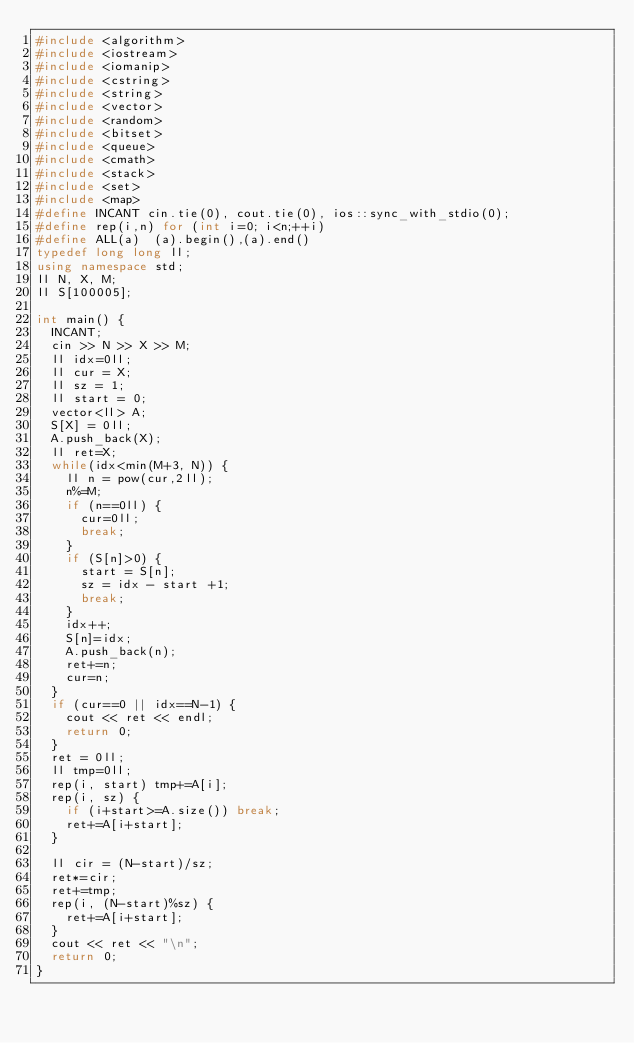<code> <loc_0><loc_0><loc_500><loc_500><_C++_>#include <algorithm>
#include <iostream>
#include <iomanip>
#include <cstring>
#include <string>
#include <vector>
#include <random>
#include <bitset>
#include <queue>
#include <cmath>
#include <stack>
#include <set>
#include <map>
#define INCANT cin.tie(0), cout.tie(0), ios::sync_with_stdio(0);
#define rep(i,n) for (int i=0; i<n;++i)
#define ALL(a)  (a).begin(),(a).end()
typedef long long ll;
using namespace std;
ll N, X, M;
ll S[100005];

int main() {
  INCANT;
  cin >> N >> X >> M;
  ll idx=0ll;
  ll cur = X;
  ll sz = 1;
  ll start = 0;
  vector<ll> A;
  S[X] = 0ll;
  A.push_back(X);
  ll ret=X;
  while(idx<min(M+3, N)) {
    ll n = pow(cur,2ll);
    n%=M;
    if (n==0ll) {
      cur=0ll;
      break;
    }
    if (S[n]>0) {
      start = S[n];
      sz = idx - start +1;
      break;
    }
    idx++;
    S[n]=idx;
    A.push_back(n);
    ret+=n;
    cur=n;
  }
  if (cur==0 || idx==N-1) {
    cout << ret << endl;
    return 0;
  }
  ret = 0ll;
  ll tmp=0ll;
  rep(i, start) tmp+=A[i];
  rep(i, sz) {
    if (i+start>=A.size()) break;
    ret+=A[i+start];
  }
  
  ll cir = (N-start)/sz;
  ret*=cir;
  ret+=tmp;
  rep(i, (N-start)%sz) {
    ret+=A[i+start];
  }
  cout << ret << "\n";
  return 0;
}</code> 